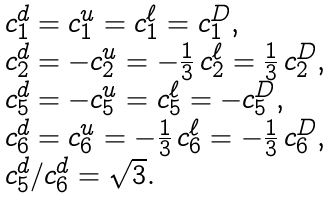<formula> <loc_0><loc_0><loc_500><loc_500>\begin{array} { l } c ^ { d } _ { 1 } = c ^ { u } _ { 1 } = c ^ { \ell } _ { 1 } = c ^ { D } _ { 1 } , \\ c ^ { d } _ { 2 } = - c ^ { u } _ { 2 } = - \frac { 1 } { 3 } \, c ^ { \ell } _ { 2 } = \frac { 1 } { 3 } \, c ^ { D } _ { 2 } , \\ c ^ { d } _ { 5 } = - c ^ { u } _ { 5 } = c ^ { \ell } _ { 5 } = - c ^ { D } _ { 5 } , \\ c ^ { d } _ { 6 } = c ^ { u } _ { 6 } = - \frac { 1 } { 3 } \, c ^ { \ell } _ { 6 } = - \frac { 1 } { 3 } \, c ^ { D } _ { 6 } , \\ c ^ { d } _ { 5 } / c ^ { d } _ { 6 } = \sqrt { 3 } . \end{array}</formula> 